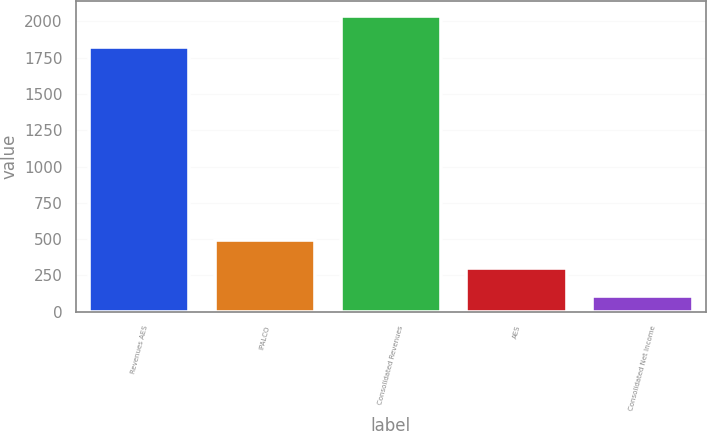Convert chart. <chart><loc_0><loc_0><loc_500><loc_500><bar_chart><fcel>Revenues AES<fcel>IPALCO<fcel>Consolidated Revenues<fcel>AES<fcel>Consolidated Net Income<nl><fcel>1820<fcel>495.8<fcel>2035<fcel>303.4<fcel>111<nl></chart> 